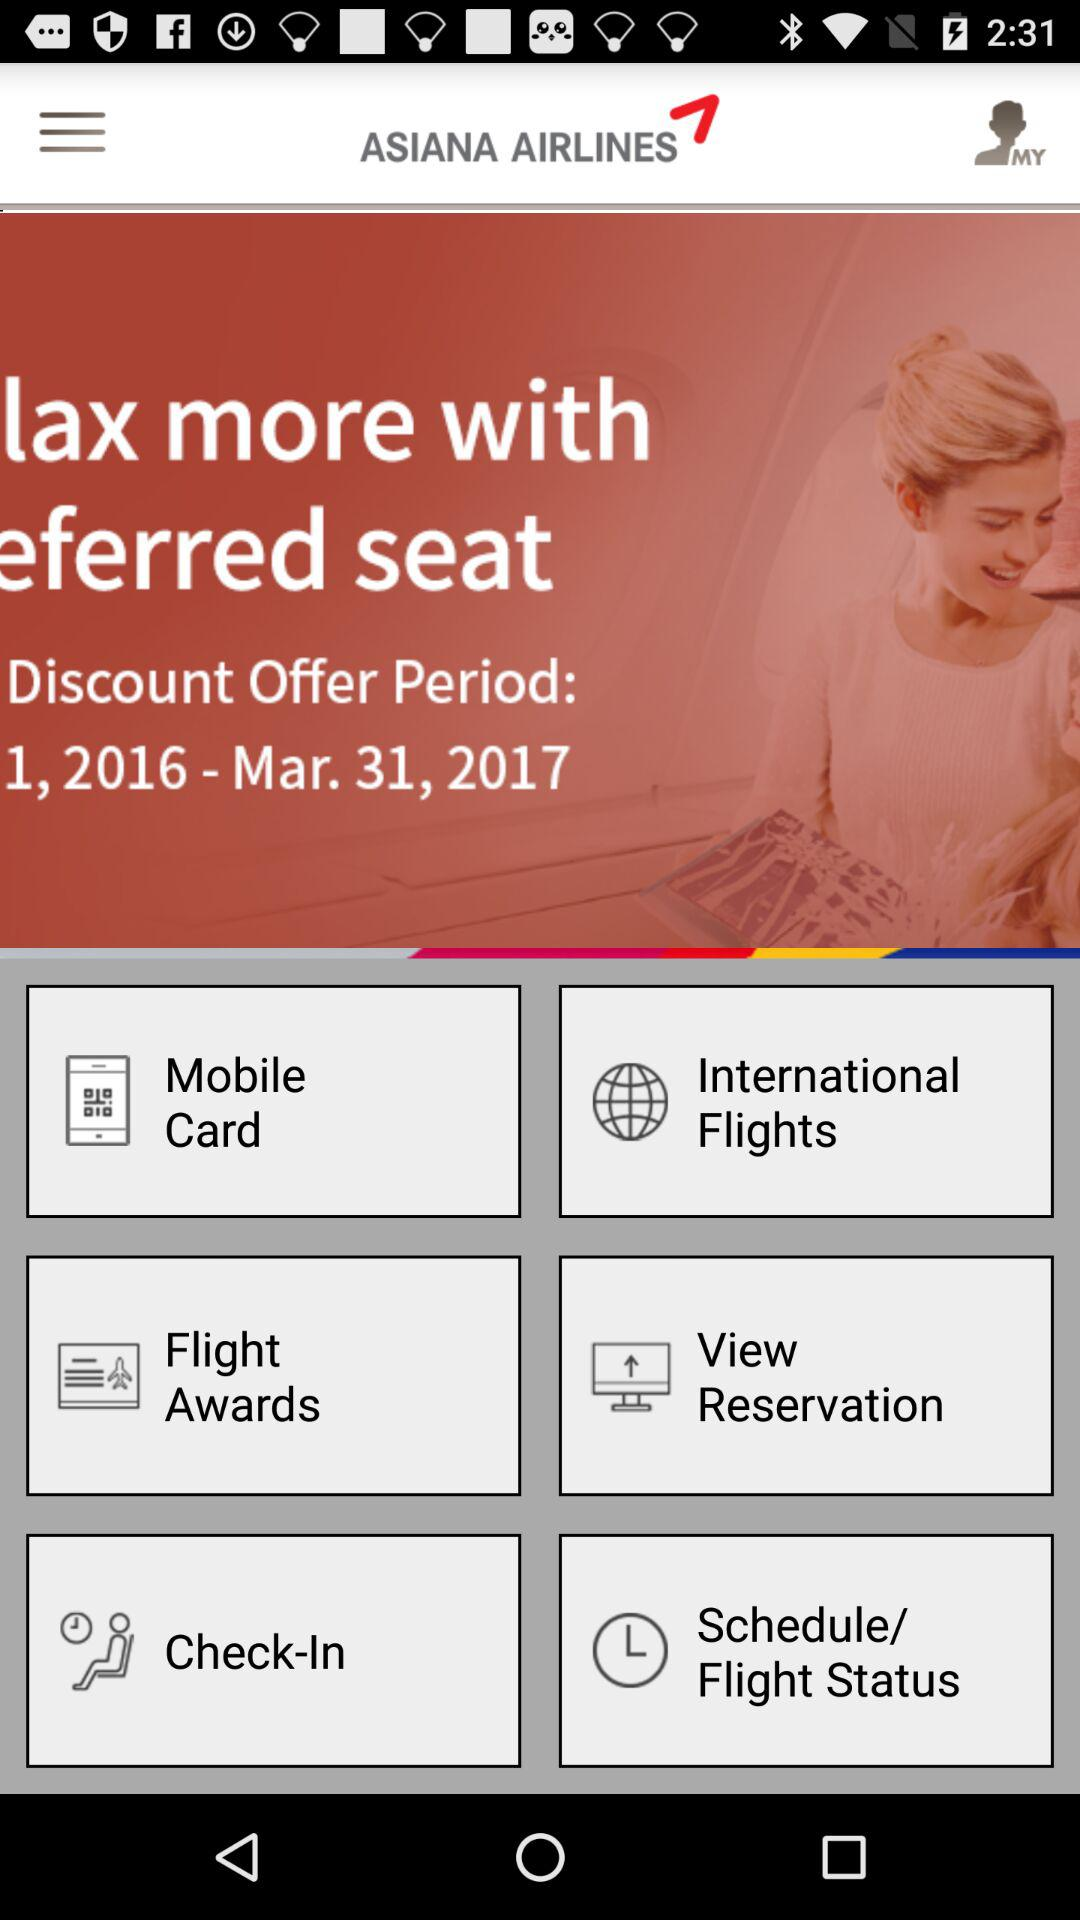How long is the Asiana Airlines discount offer period? The discount offer period is till March 31, 2017. 